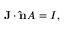Convert formula to latex. <formula><loc_0><loc_0><loc_500><loc_500>J \cdot \hat { n } A = I , \,</formula> 